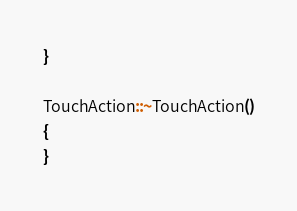<code> <loc_0><loc_0><loc_500><loc_500><_C++_>}

TouchAction::~TouchAction()
{
}
</code> 